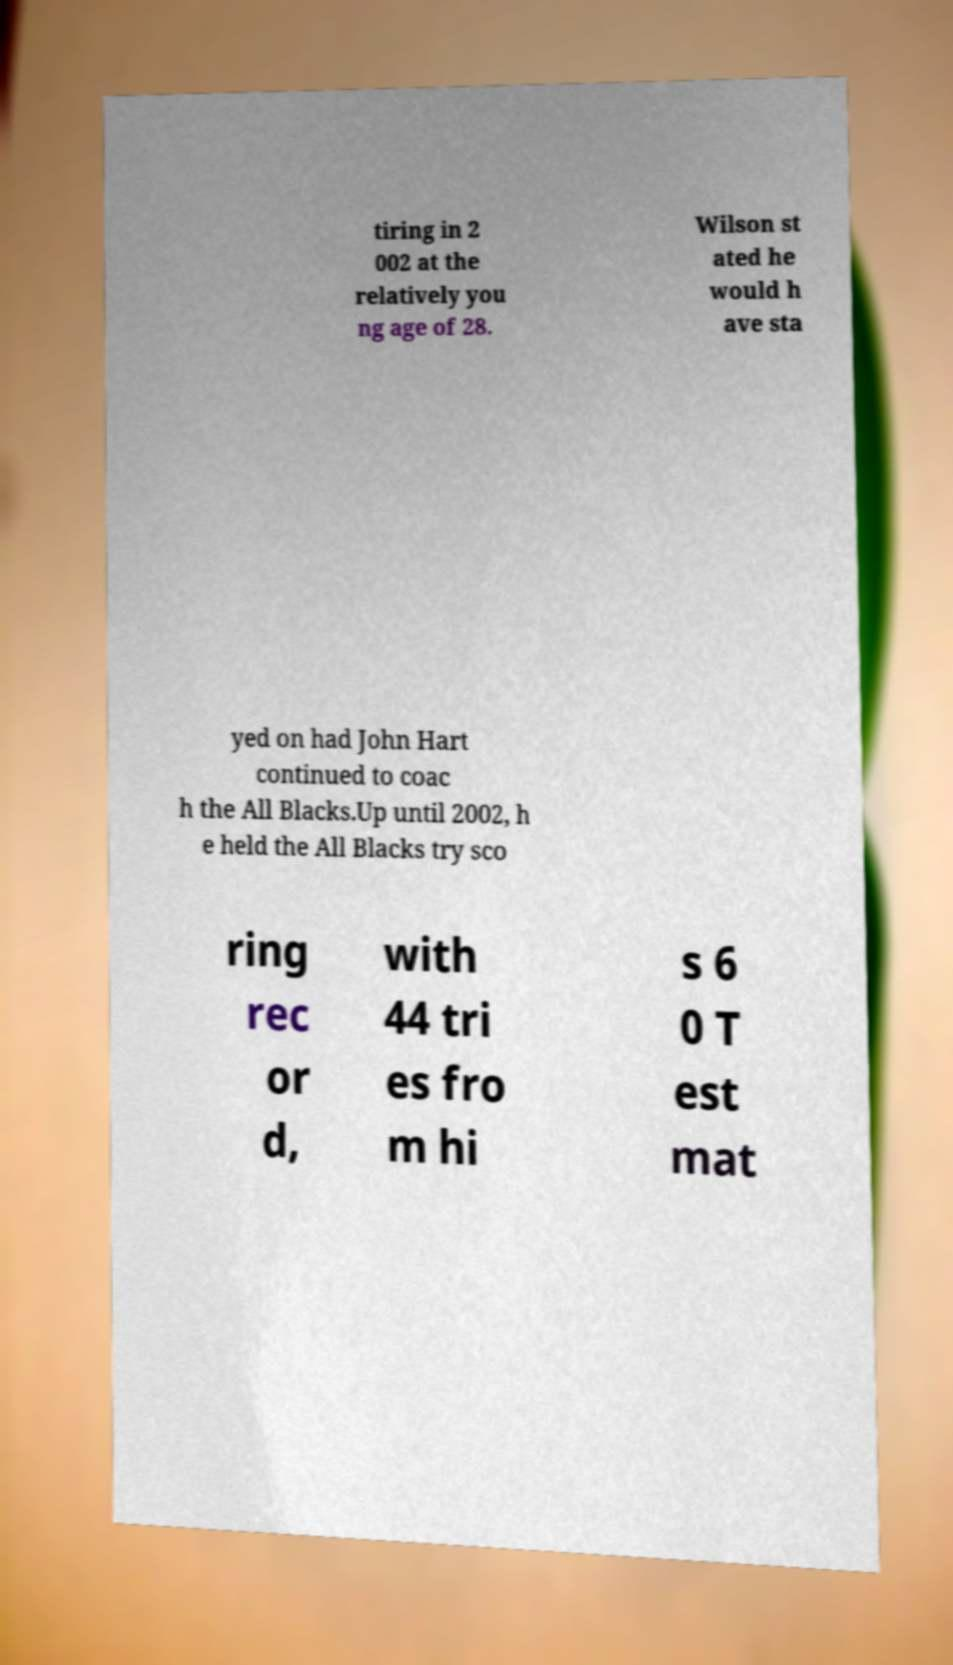For documentation purposes, I need the text within this image transcribed. Could you provide that? tiring in 2 002 at the relatively you ng age of 28. Wilson st ated he would h ave sta yed on had John Hart continued to coac h the All Blacks.Up until 2002, h e held the All Blacks try sco ring rec or d, with 44 tri es fro m hi s 6 0 T est mat 